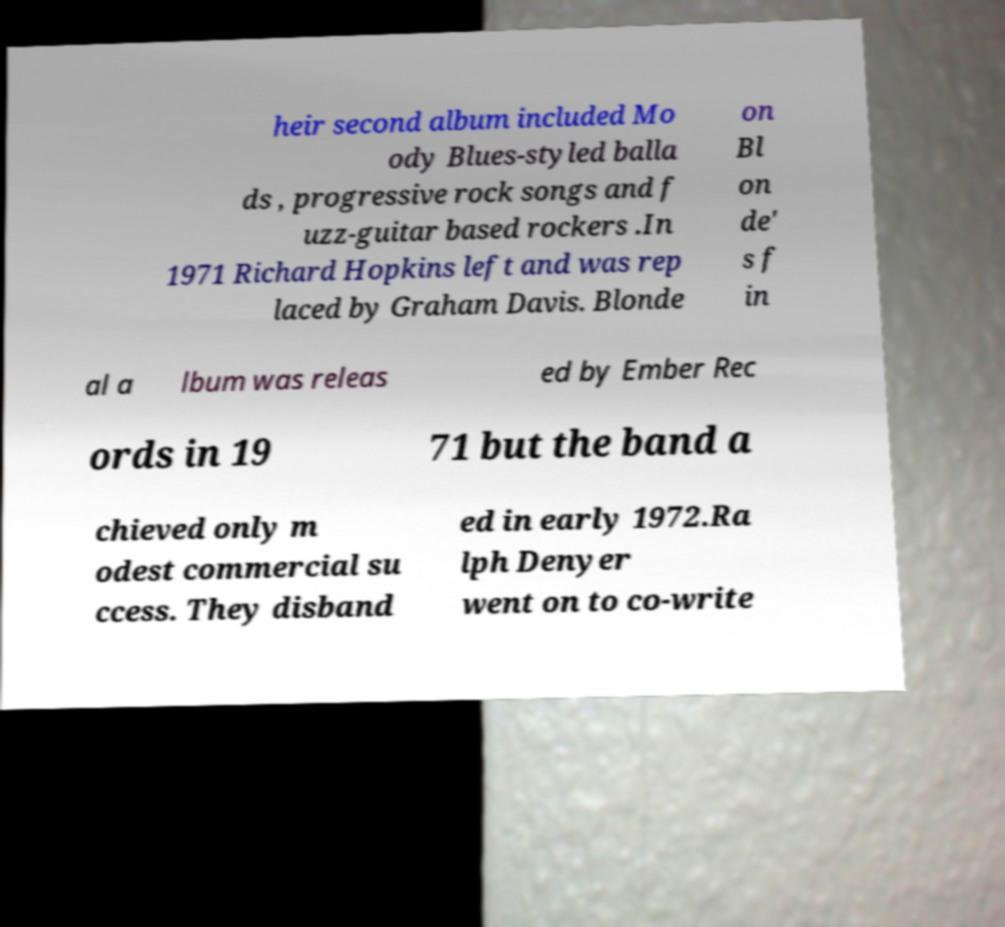Please identify and transcribe the text found in this image. heir second album included Mo ody Blues-styled balla ds , progressive rock songs and f uzz-guitar based rockers .In 1971 Richard Hopkins left and was rep laced by Graham Davis. Blonde on Bl on de' s f in al a lbum was releas ed by Ember Rec ords in 19 71 but the band a chieved only m odest commercial su ccess. They disband ed in early 1972.Ra lph Denyer went on to co-write 